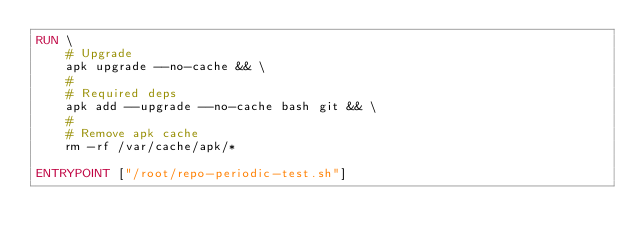<code> <loc_0><loc_0><loc_500><loc_500><_Dockerfile_>RUN \
    # Upgrade
    apk upgrade --no-cache && \
    #
    # Required deps
    apk add --upgrade --no-cache bash git && \
    #
    # Remove apk cache
    rm -rf /var/cache/apk/*

ENTRYPOINT ["/root/repo-periodic-test.sh"]
</code> 